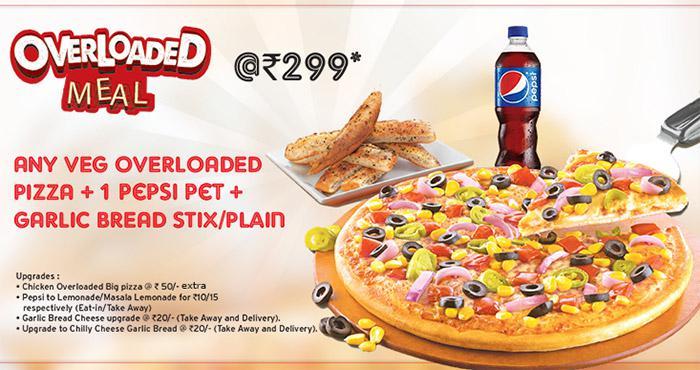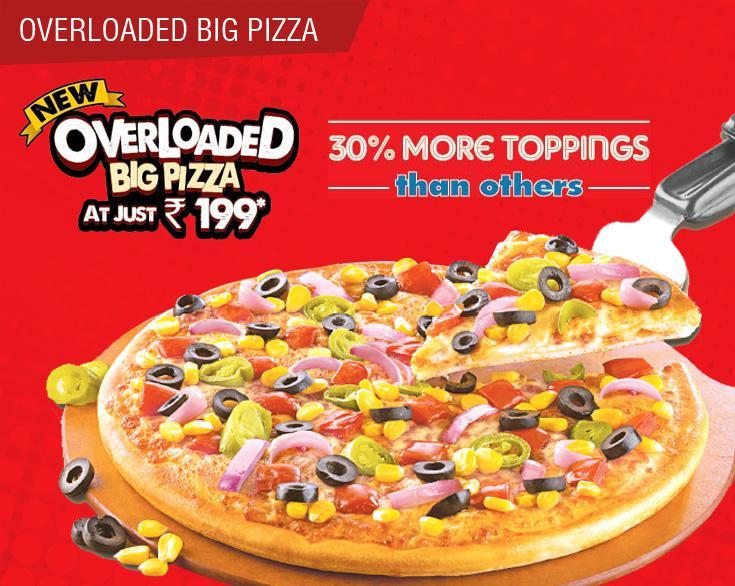The first image is the image on the left, the second image is the image on the right. For the images shown, is this caption "There are two bottles of soda pictured." true? Answer yes or no. No. The first image is the image on the left, the second image is the image on the right. Examine the images to the left and right. Is the description "A single bottle of soda sits near pizza in the image on the right." accurate? Answer yes or no. No. 